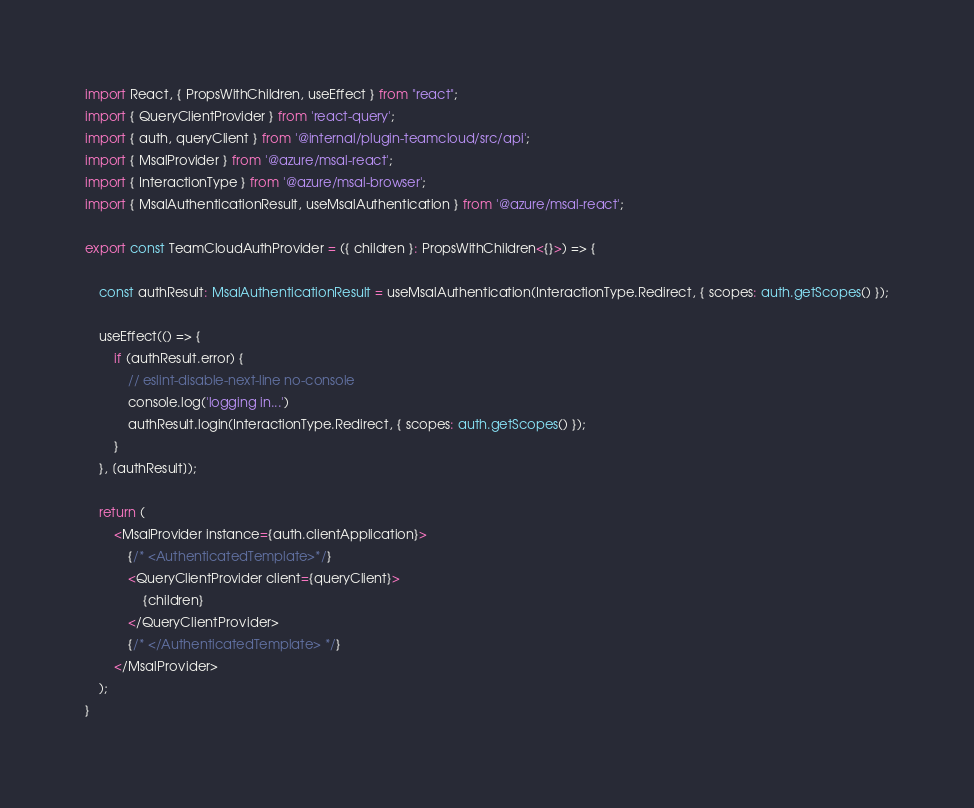Convert code to text. <code><loc_0><loc_0><loc_500><loc_500><_TypeScript_>import React, { PropsWithChildren, useEffect } from "react";
import { QueryClientProvider } from 'react-query';
import { auth, queryClient } from '@internal/plugin-teamcloud/src/api';
import { MsalProvider } from '@azure/msal-react';
import { InteractionType } from '@azure/msal-browser';
import { MsalAuthenticationResult, useMsalAuthentication } from '@azure/msal-react';

export const TeamCloudAuthProvider = ({ children }: PropsWithChildren<{}>) => {

    const authResult: MsalAuthenticationResult = useMsalAuthentication(InteractionType.Redirect, { scopes: auth.getScopes() });

    useEffect(() => {
        if (authResult.error) {
            // eslint-disable-next-line no-console
            console.log('logging in...')
            authResult.login(InteractionType.Redirect, { scopes: auth.getScopes() });
        }
    }, [authResult]);

    return (
        <MsalProvider instance={auth.clientApplication}>
            {/* <AuthenticatedTemplate>*/}
            <QueryClientProvider client={queryClient}>
                {children}
            </QueryClientProvider>
            {/* </AuthenticatedTemplate> */}
        </MsalProvider>
    );
}</code> 